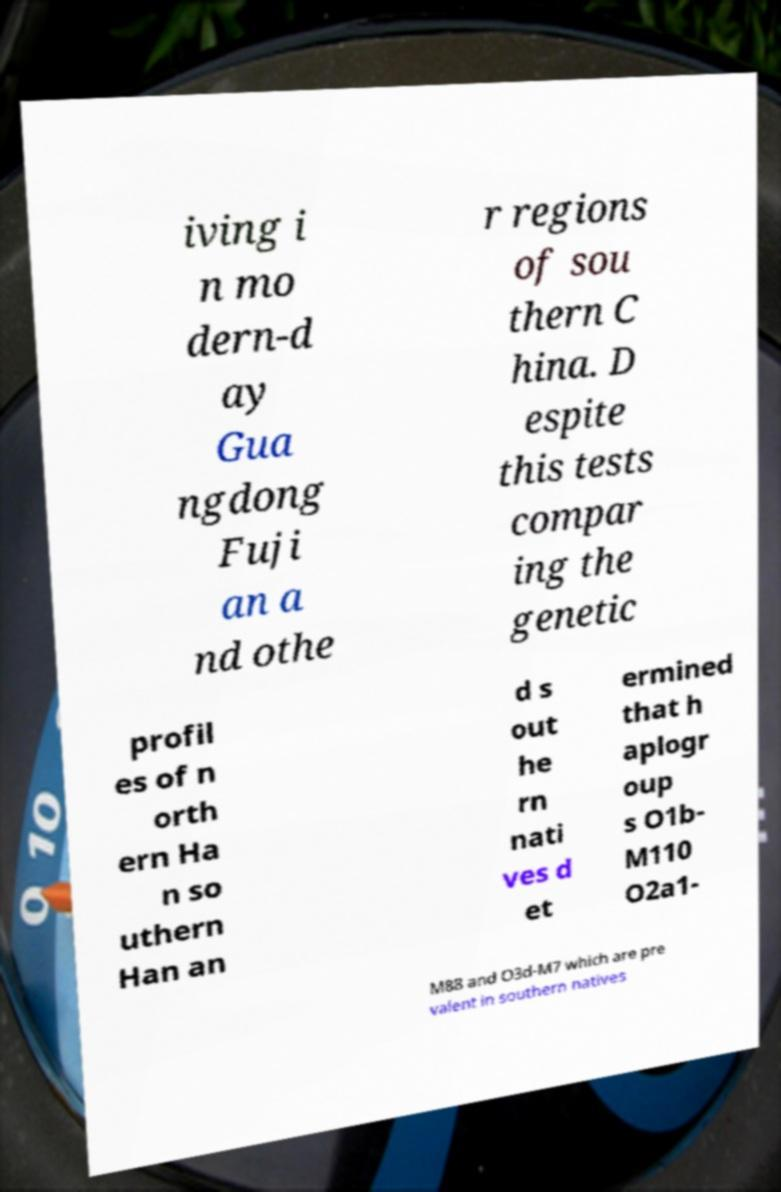Could you assist in decoding the text presented in this image and type it out clearly? iving i n mo dern-d ay Gua ngdong Fuji an a nd othe r regions of sou thern C hina. D espite this tests compar ing the genetic profil es of n orth ern Ha n so uthern Han an d s out he rn nati ves d et ermined that h aplogr oup s O1b- M110 O2a1- M88 and O3d-M7 which are pre valent in southern natives 